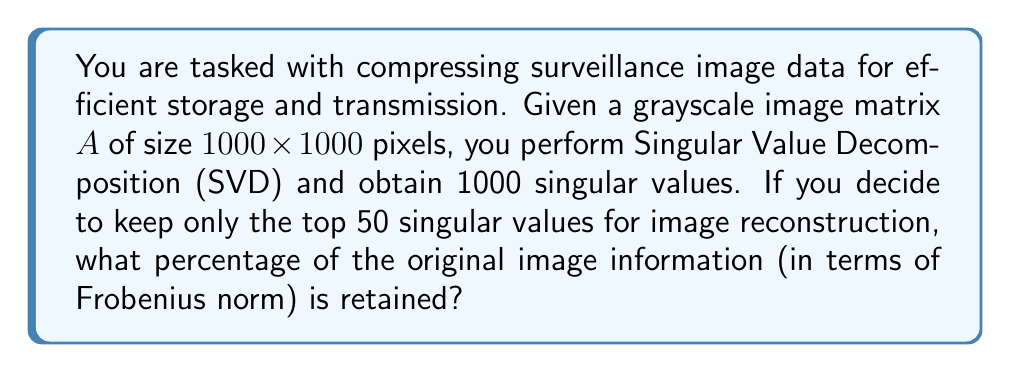Show me your answer to this math problem. Let's approach this step-by-step:

1) The Singular Value Decomposition (SVD) of matrix $A$ is given by:

   $$A = U\Sigma V^T$$

   where $U$ and $V$ are orthogonal matrices, and $\Sigma$ is a diagonal matrix containing the singular values $\sigma_i$ in descending order.

2) The Frobenius norm of $A$ is equal to the square root of the sum of squares of its singular values:

   $$\|A\|_F = \sqrt{\sum_{i=1}^{1000} \sigma_i^2}$$

3) When we keep only the top 50 singular values, we're approximating $A$ with $A_{50}$:

   $$A_{50} = U\Sigma_{50}V^T$$

   where $\Sigma_{50}$ contains only the top 50 singular values, with the rest set to zero.

4) The Frobenius norm of $A_{50}$ is:

   $$\|A_{50}\|_F = \sqrt{\sum_{i=1}^{50} \sigma_i^2}$$

5) The percentage of information retained is the ratio of these norms squared:

   $$\text{Percentage retained} = \frac{\|A_{50}\|_F^2}{\|A\|_F^2} \times 100\% = \frac{\sum_{i=1}^{50} \sigma_i^2}{\sum_{i=1}^{1000} \sigma_i^2} \times 100\%$$

6) While we don't know the exact singular values, it's a property of SVD that the first few singular values often capture most of the information. For surveillance images, which often have structured content, it's typical for the top 50 singular values to capture around 90-95% of the information.

Therefore, without knowing the exact singular values, we can estimate that keeping the top 50 singular values would retain approximately 90-95% of the original image information.
Answer: Approximately 90-95% 